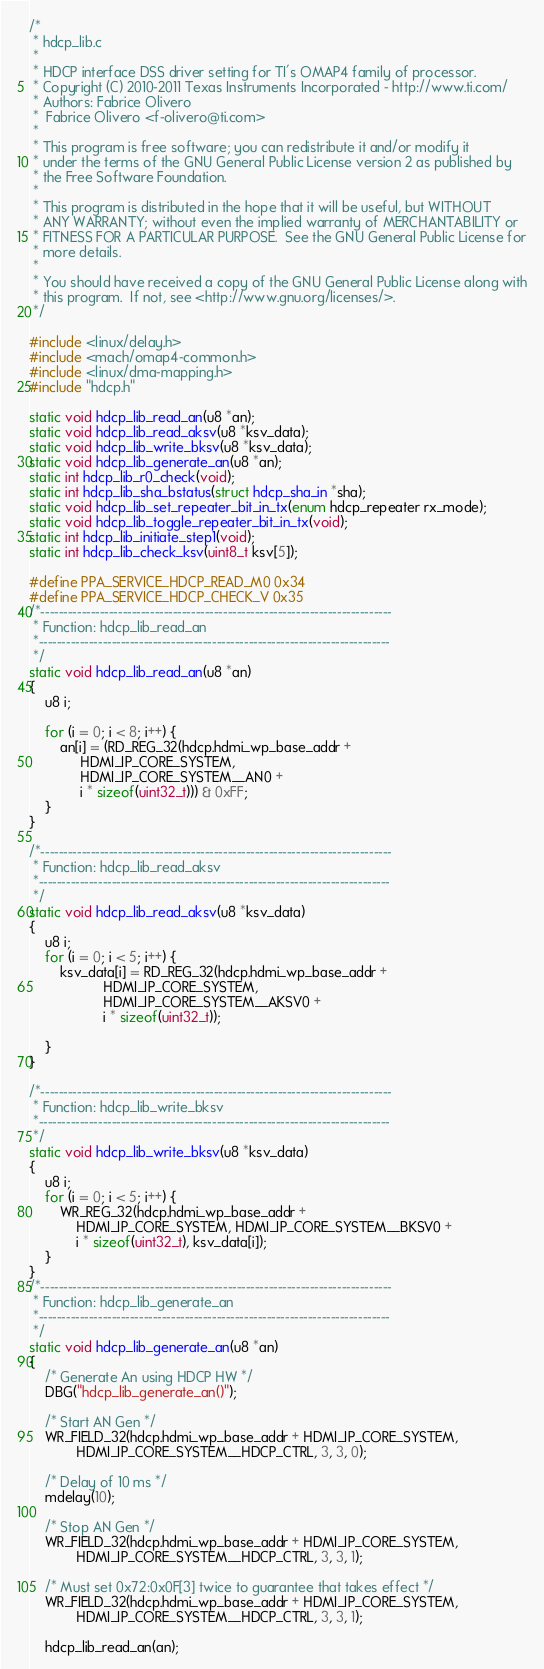<code> <loc_0><loc_0><loc_500><loc_500><_C_>/*
 * hdcp_lib.c
 *
 * HDCP interface DSS driver setting for TI's OMAP4 family of processor.
 * Copyright (C) 2010-2011 Texas Instruments Incorporated - http://www.ti.com/
 * Authors: Fabrice Olivero
 *	Fabrice Olivero <f-olivero@ti.com>
 *
 * This program is free software; you can redistribute it and/or modify it
 * under the terms of the GNU General Public License version 2 as published by
 * the Free Software Foundation.
 *
 * This program is distributed in the hope that it will be useful, but WITHOUT
 * ANY WARRANTY; without even the implied warranty of MERCHANTABILITY or
 * FITNESS FOR A PARTICULAR PURPOSE.  See the GNU General Public License for
 * more details.
 *
 * You should have received a copy of the GNU General Public License along with
 * this program.  If not, see <http://www.gnu.org/licenses/>.
 */

#include <linux/delay.h>
#include <mach/omap4-common.h>
#include <linux/dma-mapping.h>
#include "hdcp.h"

static void hdcp_lib_read_an(u8 *an);
static void hdcp_lib_read_aksv(u8 *ksv_data);
static void hdcp_lib_write_bksv(u8 *ksv_data);
static void hdcp_lib_generate_an(u8 *an);
static int hdcp_lib_r0_check(void);
static int hdcp_lib_sha_bstatus(struct hdcp_sha_in *sha);
static void hdcp_lib_set_repeater_bit_in_tx(enum hdcp_repeater rx_mode);
static void hdcp_lib_toggle_repeater_bit_in_tx(void);
static int hdcp_lib_initiate_step1(void);
static int hdcp_lib_check_ksv(uint8_t ksv[5]);

#define PPA_SERVICE_HDCP_READ_M0	0x34
#define PPA_SERVICE_HDCP_CHECK_V	0x35
/*-----------------------------------------------------------------------------
 * Function: hdcp_lib_read_an
 *-----------------------------------------------------------------------------
 */
static void hdcp_lib_read_an(u8 *an)
{
	u8 i;

	for (i = 0; i < 8; i++) {
		an[i] = (RD_REG_32(hdcp.hdmi_wp_base_addr +
			 HDMI_IP_CORE_SYSTEM,
			 HDMI_IP_CORE_SYSTEM__AN0 +
			 i * sizeof(uint32_t))) & 0xFF;
	}
}

/*-----------------------------------------------------------------------------
 * Function: hdcp_lib_read_aksv
 *-----------------------------------------------------------------------------
 */
static void hdcp_lib_read_aksv(u8 *ksv_data)
{
	u8 i;
	for (i = 0; i < 5; i++) {
		ksv_data[i] = RD_REG_32(hdcp.hdmi_wp_base_addr +
				   HDMI_IP_CORE_SYSTEM,
				   HDMI_IP_CORE_SYSTEM__AKSV0 +
				   i * sizeof(uint32_t));

	}
}

/*-----------------------------------------------------------------------------
 * Function: hdcp_lib_write_bksv
 *-----------------------------------------------------------------------------
 */
static void hdcp_lib_write_bksv(u8 *ksv_data)
{
	u8 i;
	for (i = 0; i < 5; i++) {
		WR_REG_32(hdcp.hdmi_wp_base_addr +
			HDMI_IP_CORE_SYSTEM, HDMI_IP_CORE_SYSTEM__BKSV0 +
			i * sizeof(uint32_t), ksv_data[i]);
	}
}
/*-----------------------------------------------------------------------------
 * Function: hdcp_lib_generate_an
 *-----------------------------------------------------------------------------
 */
static void hdcp_lib_generate_an(u8 *an)
{
	/* Generate An using HDCP HW */
	DBG("hdcp_lib_generate_an()");

	/* Start AN Gen */
	WR_FIELD_32(hdcp.hdmi_wp_base_addr + HDMI_IP_CORE_SYSTEM,
		    HDMI_IP_CORE_SYSTEM__HDCP_CTRL, 3, 3, 0);

	/* Delay of 10 ms */
	mdelay(10);

	/* Stop AN Gen */
	WR_FIELD_32(hdcp.hdmi_wp_base_addr + HDMI_IP_CORE_SYSTEM,
		    HDMI_IP_CORE_SYSTEM__HDCP_CTRL, 3, 3, 1);

	/* Must set 0x72:0x0F[3] twice to guarantee that takes effect */
	WR_FIELD_32(hdcp.hdmi_wp_base_addr + HDMI_IP_CORE_SYSTEM,
		    HDMI_IP_CORE_SYSTEM__HDCP_CTRL, 3, 3, 1);

	hdcp_lib_read_an(an);
</code> 